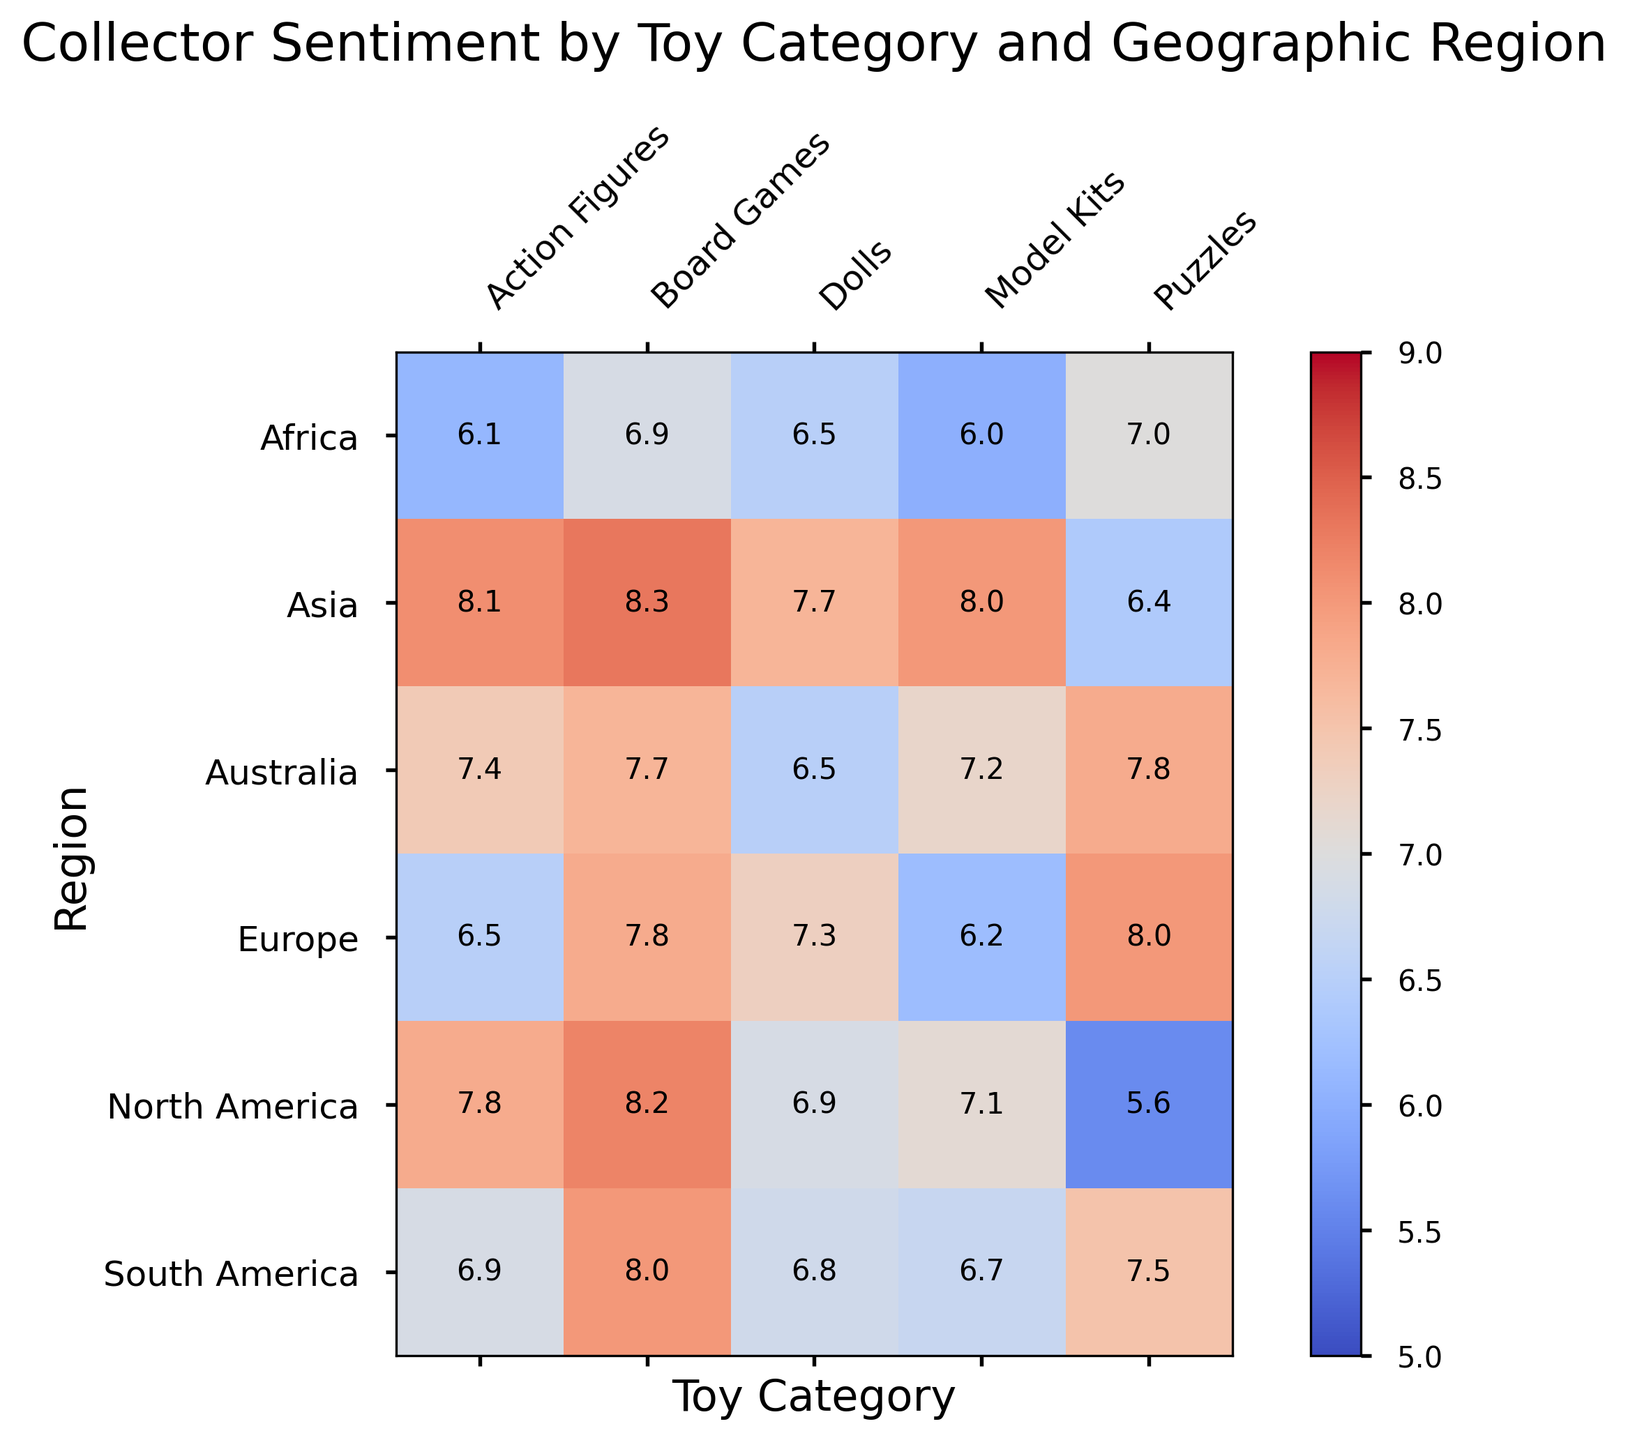What region has the highest sentiment for Action Figures? Looking at the heatmap, the highest sentiment for Action Figures is identified by the darkest red color in comparison to other regions for this category. This appears in Asia.
Answer: Asia Which toy category has the lowest sentiment in Europe? In the Europe row, the cell with the lowest sentiment is lightest. This corresponds to Model Kits with a sentiment of 6.2.
Answer: Model Kits What is the average sentiment for Board Games across all regions? To find the average sentiment for Board Games, add the sentiments from each region and divide by the number of regions: (8.2 + 7.8 + 8.3 + 8.0 + 7.7 + 6.9) / 6 = 7.98.
Answer: 7.98 Compare the sentiment for Dolls between Asia and Africa. Which one is higher? By observing the cells for Dolls in both the Asia and Africa rows, Asia has a sentiment of 7.7 while Africa has 6.5. Asia's sentiment is higher for Dolls.
Answer: Asia What is the difference in sentiment for Puzzles between North America and South America? The sentiment for Puzzles in North America is 5.6, and in South America, it is 7.5. The difference is 7.5 - 5.6 = 1.9.
Answer: 1.9 Which region has the most uniformly high sentiment across all toy categories? The region with the most uniformly high sentiment will have cells that are consistently darker red across all categories. Asia exhibits high sentiment values (8.1, 7.7, 6.4, 8.3, 8.0) mostly in the 7s and 8s, showing uniformity.
Answer: Asia In which region do Model Kits have the highest sentiment? The highest sentiment for Model Kits is represented by the darkest red in the Model Kits column. Asia has the highest sentiment for Model Kits at 8.0.
Answer: Asia How does the sentiment for Board Games in Africa compare to that in North America? North America shows a sentiment for Board Games at 8.2, while Africa shows a sentiment of 6.9. North America's sentiment is higher by 1.3.
Answer: North America Which toy category has the most consistent sentiment across all regions? By looking for similar color intensity across regions for each toy category, Board Games appears to be the most consistent with sentiments ranging closely around 7 to 8.3 across all regions.
Answer: Board Games 